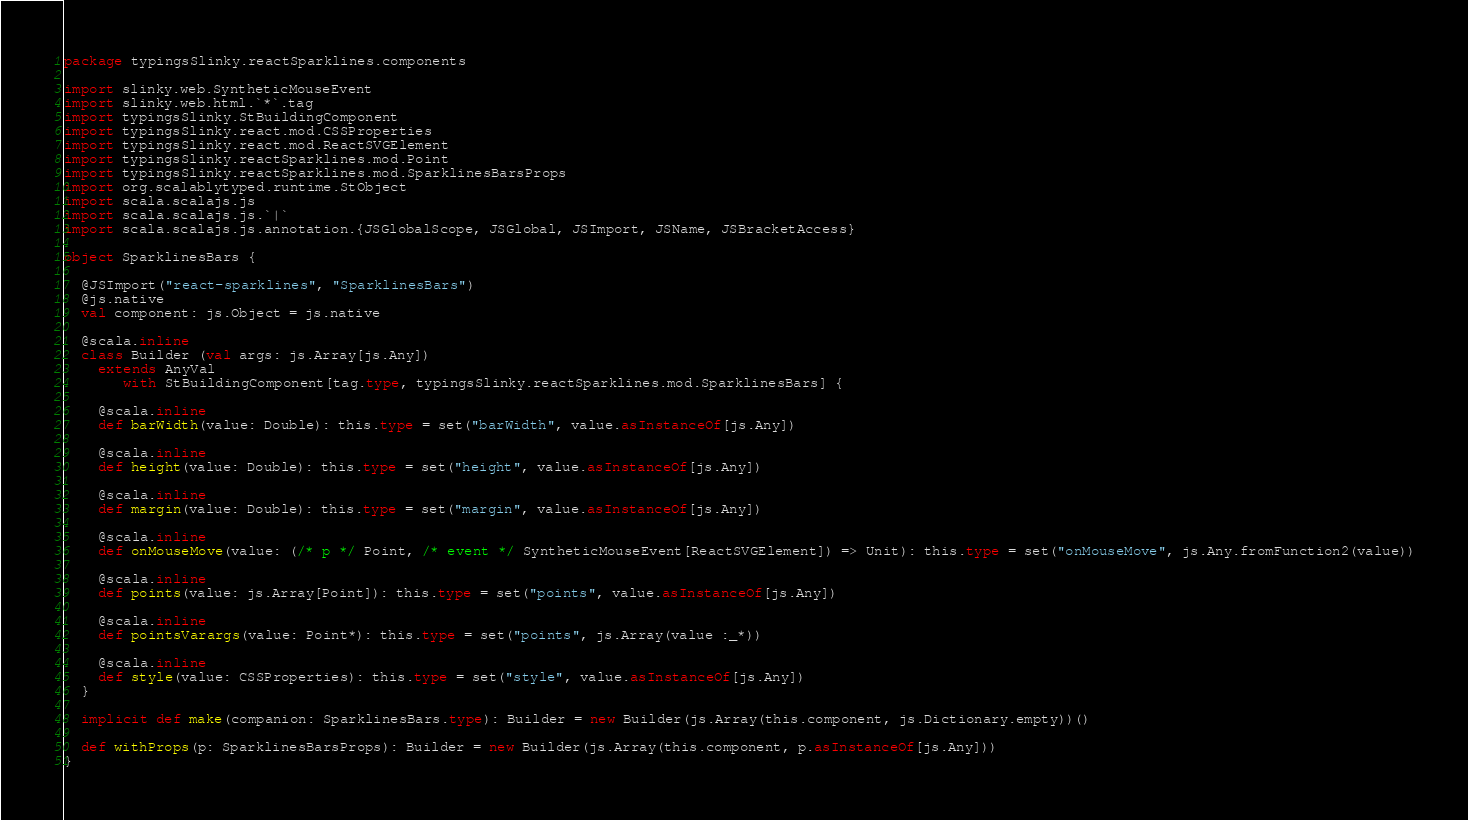Convert code to text. <code><loc_0><loc_0><loc_500><loc_500><_Scala_>package typingsSlinky.reactSparklines.components

import slinky.web.SyntheticMouseEvent
import slinky.web.html.`*`.tag
import typingsSlinky.StBuildingComponent
import typingsSlinky.react.mod.CSSProperties
import typingsSlinky.react.mod.ReactSVGElement
import typingsSlinky.reactSparklines.mod.Point
import typingsSlinky.reactSparklines.mod.SparklinesBarsProps
import org.scalablytyped.runtime.StObject
import scala.scalajs.js
import scala.scalajs.js.`|`
import scala.scalajs.js.annotation.{JSGlobalScope, JSGlobal, JSImport, JSName, JSBracketAccess}

object SparklinesBars {
  
  @JSImport("react-sparklines", "SparklinesBars")
  @js.native
  val component: js.Object = js.native
  
  @scala.inline
  class Builder (val args: js.Array[js.Any])
    extends AnyVal
       with StBuildingComponent[tag.type, typingsSlinky.reactSparklines.mod.SparklinesBars] {
    
    @scala.inline
    def barWidth(value: Double): this.type = set("barWidth", value.asInstanceOf[js.Any])
    
    @scala.inline
    def height(value: Double): this.type = set("height", value.asInstanceOf[js.Any])
    
    @scala.inline
    def margin(value: Double): this.type = set("margin", value.asInstanceOf[js.Any])
    
    @scala.inline
    def onMouseMove(value: (/* p */ Point, /* event */ SyntheticMouseEvent[ReactSVGElement]) => Unit): this.type = set("onMouseMove", js.Any.fromFunction2(value))
    
    @scala.inline
    def points(value: js.Array[Point]): this.type = set("points", value.asInstanceOf[js.Any])
    
    @scala.inline
    def pointsVarargs(value: Point*): this.type = set("points", js.Array(value :_*))
    
    @scala.inline
    def style(value: CSSProperties): this.type = set("style", value.asInstanceOf[js.Any])
  }
  
  implicit def make(companion: SparklinesBars.type): Builder = new Builder(js.Array(this.component, js.Dictionary.empty))()
  
  def withProps(p: SparklinesBarsProps): Builder = new Builder(js.Array(this.component, p.asInstanceOf[js.Any]))
}
</code> 